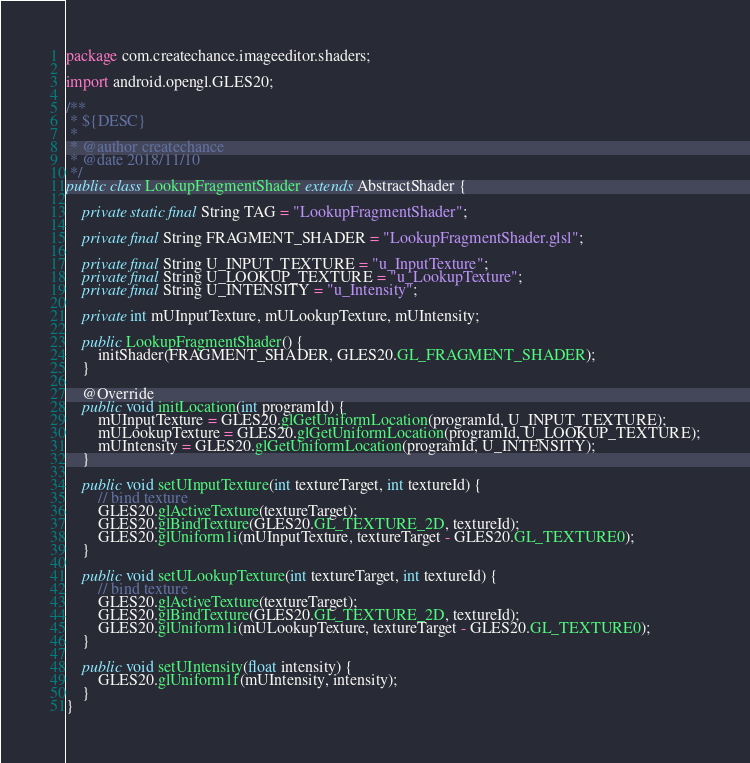<code> <loc_0><loc_0><loc_500><loc_500><_Java_>package com.createchance.imageeditor.shaders;

import android.opengl.GLES20;

/**
 * ${DESC}
 *
 * @author createchance
 * @date 2018/11/10
 */
public class LookupFragmentShader extends AbstractShader {

    private static final String TAG = "LookupFragmentShader";

    private final String FRAGMENT_SHADER = "LookupFragmentShader.glsl";

    private final String U_INPUT_TEXTURE = "u_InputTexture";
    private final String U_LOOKUP_TEXTURE = "u_LookupTexture";
    private final String U_INTENSITY = "u_Intensity";

    private int mUInputTexture, mULookupTexture, mUIntensity;

    public LookupFragmentShader() {
        initShader(FRAGMENT_SHADER, GLES20.GL_FRAGMENT_SHADER);
    }

    @Override
    public void initLocation(int programId) {
        mUInputTexture = GLES20.glGetUniformLocation(programId, U_INPUT_TEXTURE);
        mULookupTexture = GLES20.glGetUniformLocation(programId, U_LOOKUP_TEXTURE);
        mUIntensity = GLES20.glGetUniformLocation(programId, U_INTENSITY);
    }

    public void setUInputTexture(int textureTarget, int textureId) {
        // bind texture
        GLES20.glActiveTexture(textureTarget);
        GLES20.glBindTexture(GLES20.GL_TEXTURE_2D, textureId);
        GLES20.glUniform1i(mUInputTexture, textureTarget - GLES20.GL_TEXTURE0);
    }

    public void setULookupTexture(int textureTarget, int textureId) {
        // bind texture
        GLES20.glActiveTexture(textureTarget);
        GLES20.glBindTexture(GLES20.GL_TEXTURE_2D, textureId);
        GLES20.glUniform1i(mULookupTexture, textureTarget - GLES20.GL_TEXTURE0);
    }

    public void setUIntensity(float intensity) {
        GLES20.glUniform1f(mUIntensity, intensity);
    }
}
</code> 